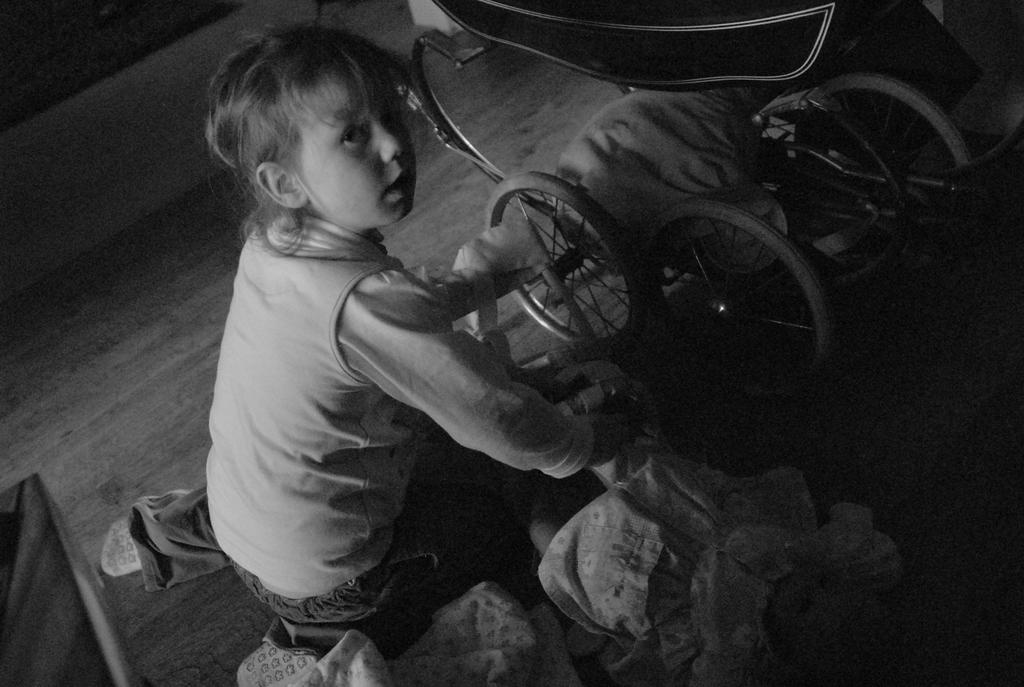What is the color scheme of the image? The image is black and white. Who is the main subject in the image? There is a girl in the center of the image. What is the girl using or sitting on in the image? There is a wheelchair in the image. What type of flooring is visible at the bottom of the image? There is wooden flooring at the bottom of the image. What type of brush is being used to apply the jelly in the image? There is no brush or jelly present in the image. How is the girl being protected from the poison in the image? There is no mention of poison in the image; the girl is sitting in a wheelchair. 